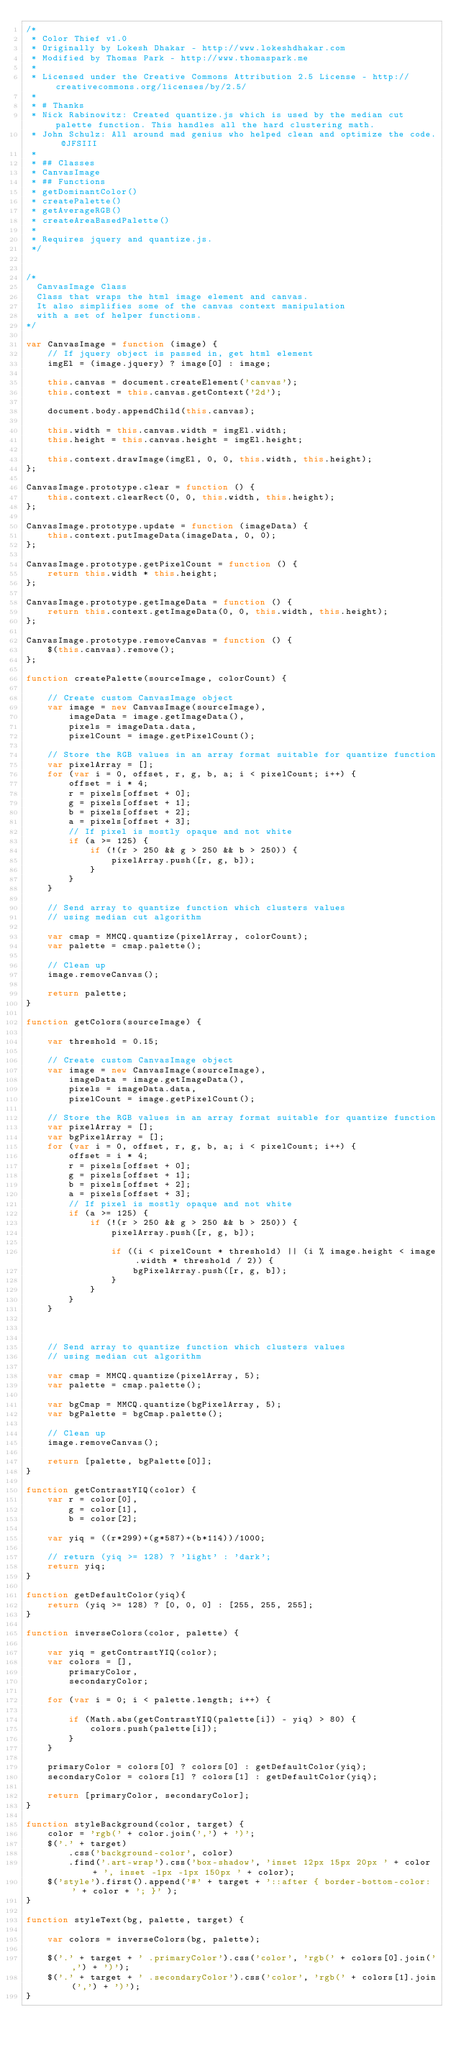Convert code to text. <code><loc_0><loc_0><loc_500><loc_500><_JavaScript_>/*
 * Color Thief v1.0
 * Originally by Lokesh Dhakar - http://www.lokeshdhakar.com
 * Modified by Thomas Park - http://www.thomaspark.me
 *
 * Licensed under the Creative Commons Attribution 2.5 License - http://creativecommons.org/licenses/by/2.5/
 *
 * # Thanks
 * Nick Rabinowitz: Created quantize.js which is used by the median cut palette function. This handles all the hard clustering math.
 * John Schulz: All around mad genius who helped clean and optimize the code. @JFSIII
 *
 * ## Classes
 * CanvasImage
 * ## Functions
 * getDominantColor()
 * createPalette()
 * getAverageRGB()
 * createAreaBasedPalette()
 *
 * Requires jquery and quantize.js.
 */


/*
  CanvasImage Class
  Class that wraps the html image element and canvas.
  It also simplifies some of the canvas context manipulation
  with a set of helper functions.
*/

var CanvasImage = function (image) {
    // If jquery object is passed in, get html element
    imgEl = (image.jquery) ? image[0] : image;

    this.canvas = document.createElement('canvas');
    this.context = this.canvas.getContext('2d');

    document.body.appendChild(this.canvas);

    this.width = this.canvas.width = imgEl.width;
    this.height = this.canvas.height = imgEl.height;

    this.context.drawImage(imgEl, 0, 0, this.width, this.height);
};

CanvasImage.prototype.clear = function () {
    this.context.clearRect(0, 0, this.width, this.height);
};

CanvasImage.prototype.update = function (imageData) {
    this.context.putImageData(imageData, 0, 0);
};

CanvasImage.prototype.getPixelCount = function () {
    return this.width * this.height;
};

CanvasImage.prototype.getImageData = function () {
    return this.context.getImageData(0, 0, this.width, this.height);
};

CanvasImage.prototype.removeCanvas = function () {
    $(this.canvas).remove();
};

function createPalette(sourceImage, colorCount) {

    // Create custom CanvasImage object
    var image = new CanvasImage(sourceImage),
        imageData = image.getImageData(),
        pixels = imageData.data,
        pixelCount = image.getPixelCount();

    // Store the RGB values in an array format suitable for quantize function
    var pixelArray = [];
    for (var i = 0, offset, r, g, b, a; i < pixelCount; i++) {
        offset = i * 4;
        r = pixels[offset + 0];
        g = pixels[offset + 1];
        b = pixels[offset + 2];
        a = pixels[offset + 3];
        // If pixel is mostly opaque and not white
        if (a >= 125) {
            if (!(r > 250 && g > 250 && b > 250)) {
                pixelArray.push([r, g, b]);
            }
        }
    }

    // Send array to quantize function which clusters values
    // using median cut algorithm

    var cmap = MMCQ.quantize(pixelArray, colorCount);
    var palette = cmap.palette();

    // Clean up
    image.removeCanvas();

    return palette;
}

function getColors(sourceImage) {

    var threshold = 0.15;

    // Create custom CanvasImage object
    var image = new CanvasImage(sourceImage),
        imageData = image.getImageData(),
        pixels = imageData.data,
        pixelCount = image.getPixelCount();

    // Store the RGB values in an array format suitable for quantize function
    var pixelArray = [];
    var bgPixelArray = [];
    for (var i = 0, offset, r, g, b, a; i < pixelCount; i++) {
        offset = i * 4;
        r = pixels[offset + 0];
        g = pixels[offset + 1];
        b = pixels[offset + 2];
        a = pixels[offset + 3];
        // If pixel is mostly opaque and not white
        if (a >= 125) {
            if (!(r > 250 && g > 250 && b > 250)) {
                pixelArray.push([r, g, b]);

                if ((i < pixelCount * threshold) || (i % image.height < image.width * threshold / 2)) {
                    bgPixelArray.push([r, g, b]);
                }
            }
        }
    }



    // Send array to quantize function which clusters values
    // using median cut algorithm

    var cmap = MMCQ.quantize(pixelArray, 5);
    var palette = cmap.palette();

    var bgCmap = MMCQ.quantize(bgPixelArray, 5);
    var bgPalette = bgCmap.palette();

    // Clean up
    image.removeCanvas();

    return [palette, bgPalette[0]];
}

function getContrastYIQ(color) {
    var r = color[0],
        g = color[1],
        b = color[2];

    var yiq = ((r*299)+(g*587)+(b*114))/1000;

    // return (yiq >= 128) ? 'light' : 'dark';
    return yiq;
}

function getDefaultColor(yiq){
    return (yiq >= 128) ? [0, 0, 0] : [255, 255, 255];
}

function inverseColors(color, palette) {

    var yiq = getContrastYIQ(color);
    var colors = [],
        primaryColor,
        secondaryColor;

    for (var i = 0; i < palette.length; i++) {

        if (Math.abs(getContrastYIQ(palette[i]) - yiq) > 80) {
            colors.push(palette[i]);
        }
    }

    primaryColor = colors[0] ? colors[0] : getDefaultColor(yiq);
    secondaryColor = colors[1] ? colors[1] : getDefaultColor(yiq);

    return [primaryColor, secondaryColor];
}

function styleBackground(color, target) {
    color = 'rgb(' + color.join(',') + ')';
    $('.' + target)
        .css('background-color', color)
        .find('.art-wrap').css('box-shadow', 'inset 12px 15px 20px ' + color + ', inset -1px -1px 150px ' + color);
    $('style').first().append('#' + target + '::after { border-bottom-color: ' + color + '; }' );
}

function styleText(bg, palette, target) {

    var colors = inverseColors(bg, palette);

    $('.' + target + ' .primaryColor').css('color', 'rgb(' + colors[0].join(',') + ')');
    $('.' + target + ' .secondaryColor').css('color', 'rgb(' + colors[1].join(',') + ')');
}
</code> 